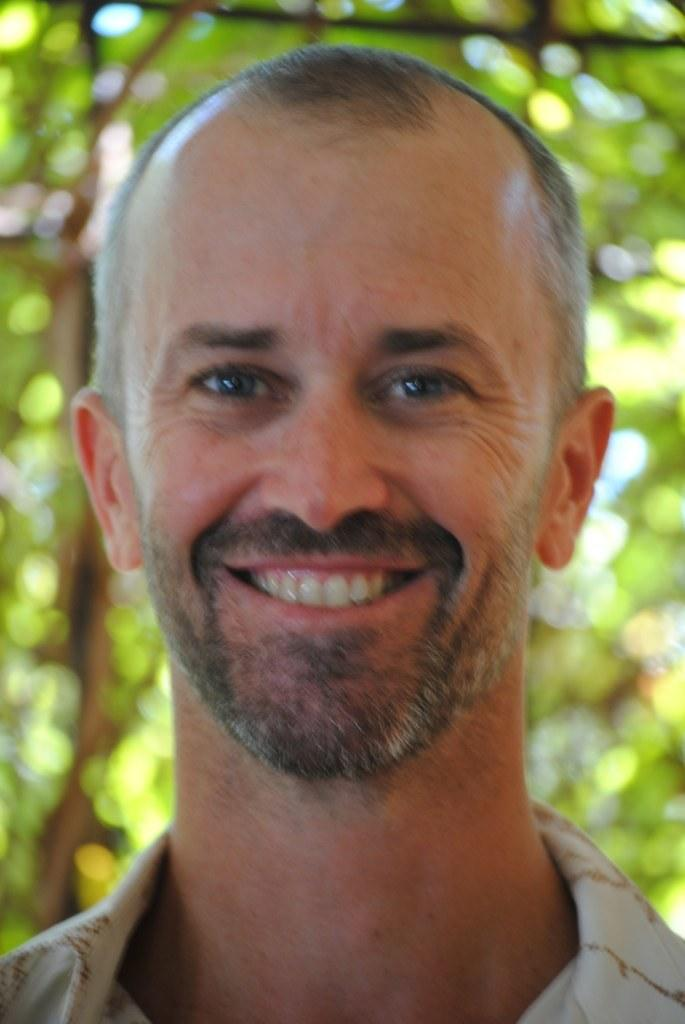Who or what is present in the image? There is a person in the image. What is the person wearing? The person is wearing a white shirt. What can be seen in the background of the image? There are plants in the background of the image. What is the color of the plants? The plants are green in color. How many chickens are participating in the competition in the image? There are no chickens or competitions present in the image. 